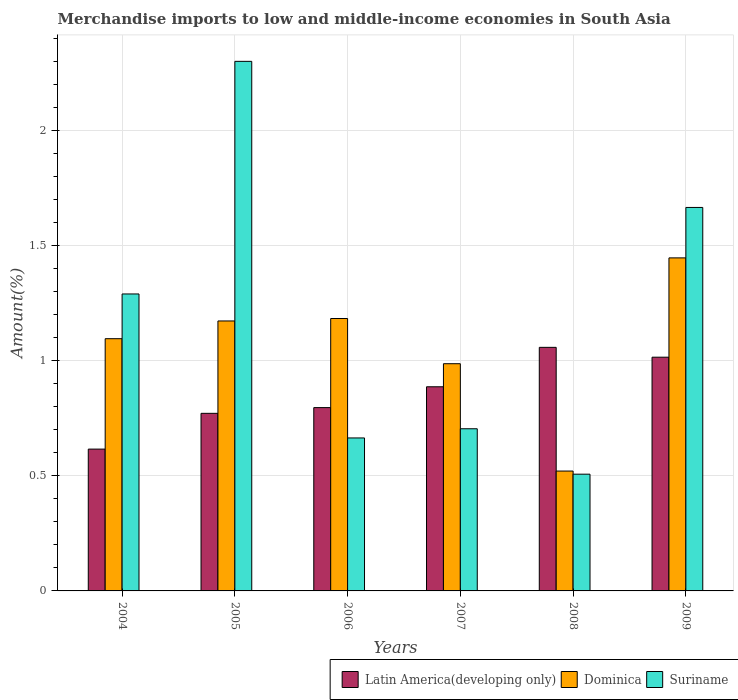How many different coloured bars are there?
Your answer should be very brief. 3. What is the percentage of amount earned from merchandise imports in Latin America(developing only) in 2005?
Your answer should be compact. 0.77. Across all years, what is the maximum percentage of amount earned from merchandise imports in Suriname?
Make the answer very short. 2.3. Across all years, what is the minimum percentage of amount earned from merchandise imports in Dominica?
Provide a succinct answer. 0.52. What is the total percentage of amount earned from merchandise imports in Suriname in the graph?
Your response must be concise. 7.13. What is the difference between the percentage of amount earned from merchandise imports in Latin America(developing only) in 2004 and that in 2006?
Provide a succinct answer. -0.18. What is the difference between the percentage of amount earned from merchandise imports in Latin America(developing only) in 2009 and the percentage of amount earned from merchandise imports in Suriname in 2004?
Your answer should be compact. -0.27. What is the average percentage of amount earned from merchandise imports in Dominica per year?
Provide a succinct answer. 1.07. In the year 2006, what is the difference between the percentage of amount earned from merchandise imports in Dominica and percentage of amount earned from merchandise imports in Latin America(developing only)?
Your response must be concise. 0.39. What is the ratio of the percentage of amount earned from merchandise imports in Latin America(developing only) in 2004 to that in 2005?
Make the answer very short. 0.8. Is the percentage of amount earned from merchandise imports in Suriname in 2004 less than that in 2008?
Ensure brevity in your answer.  No. Is the difference between the percentage of amount earned from merchandise imports in Dominica in 2006 and 2007 greater than the difference between the percentage of amount earned from merchandise imports in Latin America(developing only) in 2006 and 2007?
Offer a terse response. Yes. What is the difference between the highest and the second highest percentage of amount earned from merchandise imports in Latin America(developing only)?
Give a very brief answer. 0.04. What is the difference between the highest and the lowest percentage of amount earned from merchandise imports in Dominica?
Your answer should be compact. 0.93. In how many years, is the percentage of amount earned from merchandise imports in Suriname greater than the average percentage of amount earned from merchandise imports in Suriname taken over all years?
Ensure brevity in your answer.  3. What does the 2nd bar from the left in 2006 represents?
Offer a terse response. Dominica. What does the 1st bar from the right in 2007 represents?
Make the answer very short. Suriname. How many bars are there?
Your answer should be compact. 18. Are the values on the major ticks of Y-axis written in scientific E-notation?
Make the answer very short. No. Does the graph contain grids?
Your response must be concise. Yes. Where does the legend appear in the graph?
Offer a terse response. Bottom right. What is the title of the graph?
Offer a very short reply. Merchandise imports to low and middle-income economies in South Asia. What is the label or title of the X-axis?
Your response must be concise. Years. What is the label or title of the Y-axis?
Keep it short and to the point. Amount(%). What is the Amount(%) in Latin America(developing only) in 2004?
Keep it short and to the point. 0.62. What is the Amount(%) in Dominica in 2004?
Your response must be concise. 1.1. What is the Amount(%) in Suriname in 2004?
Make the answer very short. 1.29. What is the Amount(%) of Latin America(developing only) in 2005?
Give a very brief answer. 0.77. What is the Amount(%) in Dominica in 2005?
Provide a succinct answer. 1.17. What is the Amount(%) in Suriname in 2005?
Your answer should be very brief. 2.3. What is the Amount(%) of Latin America(developing only) in 2006?
Your answer should be compact. 0.8. What is the Amount(%) of Dominica in 2006?
Offer a terse response. 1.18. What is the Amount(%) in Suriname in 2006?
Offer a terse response. 0.66. What is the Amount(%) of Latin America(developing only) in 2007?
Your response must be concise. 0.89. What is the Amount(%) in Dominica in 2007?
Ensure brevity in your answer.  0.99. What is the Amount(%) in Suriname in 2007?
Your answer should be very brief. 0.7. What is the Amount(%) of Latin America(developing only) in 2008?
Your answer should be very brief. 1.06. What is the Amount(%) of Dominica in 2008?
Offer a terse response. 0.52. What is the Amount(%) in Suriname in 2008?
Keep it short and to the point. 0.51. What is the Amount(%) in Latin America(developing only) in 2009?
Ensure brevity in your answer.  1.01. What is the Amount(%) in Dominica in 2009?
Give a very brief answer. 1.45. What is the Amount(%) in Suriname in 2009?
Provide a succinct answer. 1.67. Across all years, what is the maximum Amount(%) in Latin America(developing only)?
Provide a succinct answer. 1.06. Across all years, what is the maximum Amount(%) of Dominica?
Ensure brevity in your answer.  1.45. Across all years, what is the maximum Amount(%) in Suriname?
Ensure brevity in your answer.  2.3. Across all years, what is the minimum Amount(%) in Latin America(developing only)?
Your response must be concise. 0.62. Across all years, what is the minimum Amount(%) of Dominica?
Keep it short and to the point. 0.52. Across all years, what is the minimum Amount(%) of Suriname?
Provide a short and direct response. 0.51. What is the total Amount(%) of Latin America(developing only) in the graph?
Offer a very short reply. 5.14. What is the total Amount(%) in Dominica in the graph?
Your answer should be very brief. 6.4. What is the total Amount(%) of Suriname in the graph?
Provide a short and direct response. 7.13. What is the difference between the Amount(%) in Latin America(developing only) in 2004 and that in 2005?
Offer a very short reply. -0.16. What is the difference between the Amount(%) in Dominica in 2004 and that in 2005?
Provide a short and direct response. -0.08. What is the difference between the Amount(%) of Suriname in 2004 and that in 2005?
Provide a succinct answer. -1.01. What is the difference between the Amount(%) in Latin America(developing only) in 2004 and that in 2006?
Give a very brief answer. -0.18. What is the difference between the Amount(%) of Dominica in 2004 and that in 2006?
Ensure brevity in your answer.  -0.09. What is the difference between the Amount(%) of Suriname in 2004 and that in 2006?
Provide a short and direct response. 0.63. What is the difference between the Amount(%) in Latin America(developing only) in 2004 and that in 2007?
Provide a short and direct response. -0.27. What is the difference between the Amount(%) in Dominica in 2004 and that in 2007?
Your answer should be compact. 0.11. What is the difference between the Amount(%) of Suriname in 2004 and that in 2007?
Offer a very short reply. 0.59. What is the difference between the Amount(%) in Latin America(developing only) in 2004 and that in 2008?
Keep it short and to the point. -0.44. What is the difference between the Amount(%) of Dominica in 2004 and that in 2008?
Offer a terse response. 0.57. What is the difference between the Amount(%) in Suriname in 2004 and that in 2008?
Offer a terse response. 0.78. What is the difference between the Amount(%) of Latin America(developing only) in 2004 and that in 2009?
Offer a terse response. -0.4. What is the difference between the Amount(%) of Dominica in 2004 and that in 2009?
Make the answer very short. -0.35. What is the difference between the Amount(%) in Suriname in 2004 and that in 2009?
Provide a short and direct response. -0.38. What is the difference between the Amount(%) of Latin America(developing only) in 2005 and that in 2006?
Keep it short and to the point. -0.02. What is the difference between the Amount(%) of Dominica in 2005 and that in 2006?
Provide a succinct answer. -0.01. What is the difference between the Amount(%) of Suriname in 2005 and that in 2006?
Ensure brevity in your answer.  1.64. What is the difference between the Amount(%) in Latin America(developing only) in 2005 and that in 2007?
Make the answer very short. -0.12. What is the difference between the Amount(%) in Dominica in 2005 and that in 2007?
Your answer should be very brief. 0.19. What is the difference between the Amount(%) in Suriname in 2005 and that in 2007?
Ensure brevity in your answer.  1.6. What is the difference between the Amount(%) of Latin America(developing only) in 2005 and that in 2008?
Provide a succinct answer. -0.29. What is the difference between the Amount(%) in Dominica in 2005 and that in 2008?
Keep it short and to the point. 0.65. What is the difference between the Amount(%) of Suriname in 2005 and that in 2008?
Keep it short and to the point. 1.79. What is the difference between the Amount(%) in Latin America(developing only) in 2005 and that in 2009?
Offer a terse response. -0.24. What is the difference between the Amount(%) of Dominica in 2005 and that in 2009?
Your answer should be compact. -0.27. What is the difference between the Amount(%) of Suriname in 2005 and that in 2009?
Your response must be concise. 0.63. What is the difference between the Amount(%) of Latin America(developing only) in 2006 and that in 2007?
Make the answer very short. -0.09. What is the difference between the Amount(%) of Dominica in 2006 and that in 2007?
Offer a terse response. 0.2. What is the difference between the Amount(%) of Suriname in 2006 and that in 2007?
Offer a terse response. -0.04. What is the difference between the Amount(%) in Latin America(developing only) in 2006 and that in 2008?
Your response must be concise. -0.26. What is the difference between the Amount(%) of Dominica in 2006 and that in 2008?
Provide a short and direct response. 0.66. What is the difference between the Amount(%) in Suriname in 2006 and that in 2008?
Provide a succinct answer. 0.16. What is the difference between the Amount(%) of Latin America(developing only) in 2006 and that in 2009?
Your answer should be very brief. -0.22. What is the difference between the Amount(%) in Dominica in 2006 and that in 2009?
Your response must be concise. -0.26. What is the difference between the Amount(%) in Suriname in 2006 and that in 2009?
Make the answer very short. -1. What is the difference between the Amount(%) of Latin America(developing only) in 2007 and that in 2008?
Give a very brief answer. -0.17. What is the difference between the Amount(%) of Dominica in 2007 and that in 2008?
Give a very brief answer. 0.47. What is the difference between the Amount(%) in Suriname in 2007 and that in 2008?
Provide a succinct answer. 0.2. What is the difference between the Amount(%) of Latin America(developing only) in 2007 and that in 2009?
Keep it short and to the point. -0.13. What is the difference between the Amount(%) in Dominica in 2007 and that in 2009?
Keep it short and to the point. -0.46. What is the difference between the Amount(%) in Suriname in 2007 and that in 2009?
Your response must be concise. -0.96. What is the difference between the Amount(%) in Latin America(developing only) in 2008 and that in 2009?
Offer a terse response. 0.04. What is the difference between the Amount(%) of Dominica in 2008 and that in 2009?
Offer a terse response. -0.93. What is the difference between the Amount(%) of Suriname in 2008 and that in 2009?
Provide a short and direct response. -1.16. What is the difference between the Amount(%) in Latin America(developing only) in 2004 and the Amount(%) in Dominica in 2005?
Provide a short and direct response. -0.56. What is the difference between the Amount(%) of Latin America(developing only) in 2004 and the Amount(%) of Suriname in 2005?
Provide a short and direct response. -1.68. What is the difference between the Amount(%) of Dominica in 2004 and the Amount(%) of Suriname in 2005?
Give a very brief answer. -1.2. What is the difference between the Amount(%) of Latin America(developing only) in 2004 and the Amount(%) of Dominica in 2006?
Give a very brief answer. -0.57. What is the difference between the Amount(%) of Latin America(developing only) in 2004 and the Amount(%) of Suriname in 2006?
Provide a succinct answer. -0.05. What is the difference between the Amount(%) in Dominica in 2004 and the Amount(%) in Suriname in 2006?
Provide a succinct answer. 0.43. What is the difference between the Amount(%) in Latin America(developing only) in 2004 and the Amount(%) in Dominica in 2007?
Give a very brief answer. -0.37. What is the difference between the Amount(%) in Latin America(developing only) in 2004 and the Amount(%) in Suriname in 2007?
Offer a very short reply. -0.09. What is the difference between the Amount(%) of Dominica in 2004 and the Amount(%) of Suriname in 2007?
Provide a succinct answer. 0.39. What is the difference between the Amount(%) in Latin America(developing only) in 2004 and the Amount(%) in Dominica in 2008?
Keep it short and to the point. 0.1. What is the difference between the Amount(%) in Latin America(developing only) in 2004 and the Amount(%) in Suriname in 2008?
Ensure brevity in your answer.  0.11. What is the difference between the Amount(%) of Dominica in 2004 and the Amount(%) of Suriname in 2008?
Your answer should be compact. 0.59. What is the difference between the Amount(%) of Latin America(developing only) in 2004 and the Amount(%) of Dominica in 2009?
Offer a terse response. -0.83. What is the difference between the Amount(%) of Latin America(developing only) in 2004 and the Amount(%) of Suriname in 2009?
Provide a short and direct response. -1.05. What is the difference between the Amount(%) of Dominica in 2004 and the Amount(%) of Suriname in 2009?
Offer a very short reply. -0.57. What is the difference between the Amount(%) in Latin America(developing only) in 2005 and the Amount(%) in Dominica in 2006?
Provide a short and direct response. -0.41. What is the difference between the Amount(%) of Latin America(developing only) in 2005 and the Amount(%) of Suriname in 2006?
Ensure brevity in your answer.  0.11. What is the difference between the Amount(%) of Dominica in 2005 and the Amount(%) of Suriname in 2006?
Your answer should be very brief. 0.51. What is the difference between the Amount(%) of Latin America(developing only) in 2005 and the Amount(%) of Dominica in 2007?
Offer a terse response. -0.22. What is the difference between the Amount(%) of Latin America(developing only) in 2005 and the Amount(%) of Suriname in 2007?
Offer a very short reply. 0.07. What is the difference between the Amount(%) of Dominica in 2005 and the Amount(%) of Suriname in 2007?
Ensure brevity in your answer.  0.47. What is the difference between the Amount(%) of Latin America(developing only) in 2005 and the Amount(%) of Dominica in 2008?
Provide a short and direct response. 0.25. What is the difference between the Amount(%) in Latin America(developing only) in 2005 and the Amount(%) in Suriname in 2008?
Give a very brief answer. 0.26. What is the difference between the Amount(%) in Dominica in 2005 and the Amount(%) in Suriname in 2008?
Ensure brevity in your answer.  0.67. What is the difference between the Amount(%) in Latin America(developing only) in 2005 and the Amount(%) in Dominica in 2009?
Keep it short and to the point. -0.68. What is the difference between the Amount(%) in Latin America(developing only) in 2005 and the Amount(%) in Suriname in 2009?
Your answer should be very brief. -0.89. What is the difference between the Amount(%) of Dominica in 2005 and the Amount(%) of Suriname in 2009?
Make the answer very short. -0.49. What is the difference between the Amount(%) of Latin America(developing only) in 2006 and the Amount(%) of Dominica in 2007?
Give a very brief answer. -0.19. What is the difference between the Amount(%) in Latin America(developing only) in 2006 and the Amount(%) in Suriname in 2007?
Keep it short and to the point. 0.09. What is the difference between the Amount(%) in Dominica in 2006 and the Amount(%) in Suriname in 2007?
Provide a succinct answer. 0.48. What is the difference between the Amount(%) of Latin America(developing only) in 2006 and the Amount(%) of Dominica in 2008?
Ensure brevity in your answer.  0.28. What is the difference between the Amount(%) in Latin America(developing only) in 2006 and the Amount(%) in Suriname in 2008?
Offer a terse response. 0.29. What is the difference between the Amount(%) in Dominica in 2006 and the Amount(%) in Suriname in 2008?
Offer a terse response. 0.68. What is the difference between the Amount(%) of Latin America(developing only) in 2006 and the Amount(%) of Dominica in 2009?
Offer a very short reply. -0.65. What is the difference between the Amount(%) of Latin America(developing only) in 2006 and the Amount(%) of Suriname in 2009?
Your answer should be very brief. -0.87. What is the difference between the Amount(%) of Dominica in 2006 and the Amount(%) of Suriname in 2009?
Your response must be concise. -0.48. What is the difference between the Amount(%) in Latin America(developing only) in 2007 and the Amount(%) in Dominica in 2008?
Your response must be concise. 0.37. What is the difference between the Amount(%) in Latin America(developing only) in 2007 and the Amount(%) in Suriname in 2008?
Provide a succinct answer. 0.38. What is the difference between the Amount(%) of Dominica in 2007 and the Amount(%) of Suriname in 2008?
Your answer should be compact. 0.48. What is the difference between the Amount(%) in Latin America(developing only) in 2007 and the Amount(%) in Dominica in 2009?
Offer a terse response. -0.56. What is the difference between the Amount(%) of Latin America(developing only) in 2007 and the Amount(%) of Suriname in 2009?
Provide a succinct answer. -0.78. What is the difference between the Amount(%) in Dominica in 2007 and the Amount(%) in Suriname in 2009?
Provide a short and direct response. -0.68. What is the difference between the Amount(%) in Latin America(developing only) in 2008 and the Amount(%) in Dominica in 2009?
Ensure brevity in your answer.  -0.39. What is the difference between the Amount(%) in Latin America(developing only) in 2008 and the Amount(%) in Suriname in 2009?
Keep it short and to the point. -0.61. What is the difference between the Amount(%) of Dominica in 2008 and the Amount(%) of Suriname in 2009?
Give a very brief answer. -1.14. What is the average Amount(%) of Latin America(developing only) per year?
Provide a succinct answer. 0.86. What is the average Amount(%) of Dominica per year?
Make the answer very short. 1.07. What is the average Amount(%) in Suriname per year?
Offer a terse response. 1.19. In the year 2004, what is the difference between the Amount(%) of Latin America(developing only) and Amount(%) of Dominica?
Ensure brevity in your answer.  -0.48. In the year 2004, what is the difference between the Amount(%) of Latin America(developing only) and Amount(%) of Suriname?
Ensure brevity in your answer.  -0.67. In the year 2004, what is the difference between the Amount(%) in Dominica and Amount(%) in Suriname?
Give a very brief answer. -0.19. In the year 2005, what is the difference between the Amount(%) in Latin America(developing only) and Amount(%) in Dominica?
Make the answer very short. -0.4. In the year 2005, what is the difference between the Amount(%) of Latin America(developing only) and Amount(%) of Suriname?
Ensure brevity in your answer.  -1.53. In the year 2005, what is the difference between the Amount(%) in Dominica and Amount(%) in Suriname?
Make the answer very short. -1.13. In the year 2006, what is the difference between the Amount(%) in Latin America(developing only) and Amount(%) in Dominica?
Offer a very short reply. -0.39. In the year 2006, what is the difference between the Amount(%) in Latin America(developing only) and Amount(%) in Suriname?
Give a very brief answer. 0.13. In the year 2006, what is the difference between the Amount(%) in Dominica and Amount(%) in Suriname?
Provide a short and direct response. 0.52. In the year 2007, what is the difference between the Amount(%) in Latin America(developing only) and Amount(%) in Dominica?
Provide a short and direct response. -0.1. In the year 2007, what is the difference between the Amount(%) in Latin America(developing only) and Amount(%) in Suriname?
Provide a short and direct response. 0.18. In the year 2007, what is the difference between the Amount(%) of Dominica and Amount(%) of Suriname?
Provide a short and direct response. 0.28. In the year 2008, what is the difference between the Amount(%) in Latin America(developing only) and Amount(%) in Dominica?
Give a very brief answer. 0.54. In the year 2008, what is the difference between the Amount(%) in Latin America(developing only) and Amount(%) in Suriname?
Make the answer very short. 0.55. In the year 2008, what is the difference between the Amount(%) of Dominica and Amount(%) of Suriname?
Provide a succinct answer. 0.01. In the year 2009, what is the difference between the Amount(%) in Latin America(developing only) and Amount(%) in Dominica?
Offer a terse response. -0.43. In the year 2009, what is the difference between the Amount(%) of Latin America(developing only) and Amount(%) of Suriname?
Ensure brevity in your answer.  -0.65. In the year 2009, what is the difference between the Amount(%) in Dominica and Amount(%) in Suriname?
Give a very brief answer. -0.22. What is the ratio of the Amount(%) in Latin America(developing only) in 2004 to that in 2005?
Offer a very short reply. 0.8. What is the ratio of the Amount(%) of Dominica in 2004 to that in 2005?
Ensure brevity in your answer.  0.93. What is the ratio of the Amount(%) in Suriname in 2004 to that in 2005?
Make the answer very short. 0.56. What is the ratio of the Amount(%) in Latin America(developing only) in 2004 to that in 2006?
Your answer should be very brief. 0.77. What is the ratio of the Amount(%) in Dominica in 2004 to that in 2006?
Give a very brief answer. 0.93. What is the ratio of the Amount(%) of Suriname in 2004 to that in 2006?
Keep it short and to the point. 1.94. What is the ratio of the Amount(%) of Latin America(developing only) in 2004 to that in 2007?
Provide a succinct answer. 0.69. What is the ratio of the Amount(%) of Dominica in 2004 to that in 2007?
Offer a very short reply. 1.11. What is the ratio of the Amount(%) of Suriname in 2004 to that in 2007?
Provide a short and direct response. 1.83. What is the ratio of the Amount(%) in Latin America(developing only) in 2004 to that in 2008?
Your answer should be compact. 0.58. What is the ratio of the Amount(%) of Dominica in 2004 to that in 2008?
Make the answer very short. 2.1. What is the ratio of the Amount(%) in Suriname in 2004 to that in 2008?
Your answer should be compact. 2.54. What is the ratio of the Amount(%) in Latin America(developing only) in 2004 to that in 2009?
Your answer should be very brief. 0.61. What is the ratio of the Amount(%) of Dominica in 2004 to that in 2009?
Provide a short and direct response. 0.76. What is the ratio of the Amount(%) of Suriname in 2004 to that in 2009?
Give a very brief answer. 0.77. What is the ratio of the Amount(%) in Latin America(developing only) in 2005 to that in 2006?
Provide a short and direct response. 0.97. What is the ratio of the Amount(%) of Dominica in 2005 to that in 2006?
Your answer should be compact. 0.99. What is the ratio of the Amount(%) of Suriname in 2005 to that in 2006?
Offer a terse response. 3.46. What is the ratio of the Amount(%) of Latin America(developing only) in 2005 to that in 2007?
Ensure brevity in your answer.  0.87. What is the ratio of the Amount(%) of Dominica in 2005 to that in 2007?
Give a very brief answer. 1.19. What is the ratio of the Amount(%) of Suriname in 2005 to that in 2007?
Your response must be concise. 3.27. What is the ratio of the Amount(%) in Latin America(developing only) in 2005 to that in 2008?
Offer a terse response. 0.73. What is the ratio of the Amount(%) of Dominica in 2005 to that in 2008?
Provide a succinct answer. 2.25. What is the ratio of the Amount(%) of Suriname in 2005 to that in 2008?
Provide a succinct answer. 4.54. What is the ratio of the Amount(%) in Latin America(developing only) in 2005 to that in 2009?
Your answer should be very brief. 0.76. What is the ratio of the Amount(%) in Dominica in 2005 to that in 2009?
Offer a terse response. 0.81. What is the ratio of the Amount(%) in Suriname in 2005 to that in 2009?
Offer a very short reply. 1.38. What is the ratio of the Amount(%) in Latin America(developing only) in 2006 to that in 2007?
Provide a short and direct response. 0.9. What is the ratio of the Amount(%) in Dominica in 2006 to that in 2007?
Your answer should be very brief. 1.2. What is the ratio of the Amount(%) of Suriname in 2006 to that in 2007?
Offer a terse response. 0.94. What is the ratio of the Amount(%) of Latin America(developing only) in 2006 to that in 2008?
Your answer should be compact. 0.75. What is the ratio of the Amount(%) in Dominica in 2006 to that in 2008?
Provide a succinct answer. 2.27. What is the ratio of the Amount(%) of Suriname in 2006 to that in 2008?
Provide a succinct answer. 1.31. What is the ratio of the Amount(%) of Latin America(developing only) in 2006 to that in 2009?
Offer a very short reply. 0.78. What is the ratio of the Amount(%) of Dominica in 2006 to that in 2009?
Keep it short and to the point. 0.82. What is the ratio of the Amount(%) in Suriname in 2006 to that in 2009?
Offer a terse response. 0.4. What is the ratio of the Amount(%) in Latin America(developing only) in 2007 to that in 2008?
Give a very brief answer. 0.84. What is the ratio of the Amount(%) of Dominica in 2007 to that in 2008?
Give a very brief answer. 1.9. What is the ratio of the Amount(%) of Suriname in 2007 to that in 2008?
Offer a terse response. 1.39. What is the ratio of the Amount(%) of Latin America(developing only) in 2007 to that in 2009?
Provide a short and direct response. 0.87. What is the ratio of the Amount(%) in Dominica in 2007 to that in 2009?
Provide a short and direct response. 0.68. What is the ratio of the Amount(%) of Suriname in 2007 to that in 2009?
Ensure brevity in your answer.  0.42. What is the ratio of the Amount(%) of Latin America(developing only) in 2008 to that in 2009?
Provide a short and direct response. 1.04. What is the ratio of the Amount(%) of Dominica in 2008 to that in 2009?
Provide a short and direct response. 0.36. What is the ratio of the Amount(%) in Suriname in 2008 to that in 2009?
Offer a terse response. 0.3. What is the difference between the highest and the second highest Amount(%) of Latin America(developing only)?
Give a very brief answer. 0.04. What is the difference between the highest and the second highest Amount(%) of Dominica?
Ensure brevity in your answer.  0.26. What is the difference between the highest and the second highest Amount(%) in Suriname?
Keep it short and to the point. 0.63. What is the difference between the highest and the lowest Amount(%) in Latin America(developing only)?
Offer a terse response. 0.44. What is the difference between the highest and the lowest Amount(%) of Dominica?
Provide a succinct answer. 0.93. What is the difference between the highest and the lowest Amount(%) in Suriname?
Give a very brief answer. 1.79. 